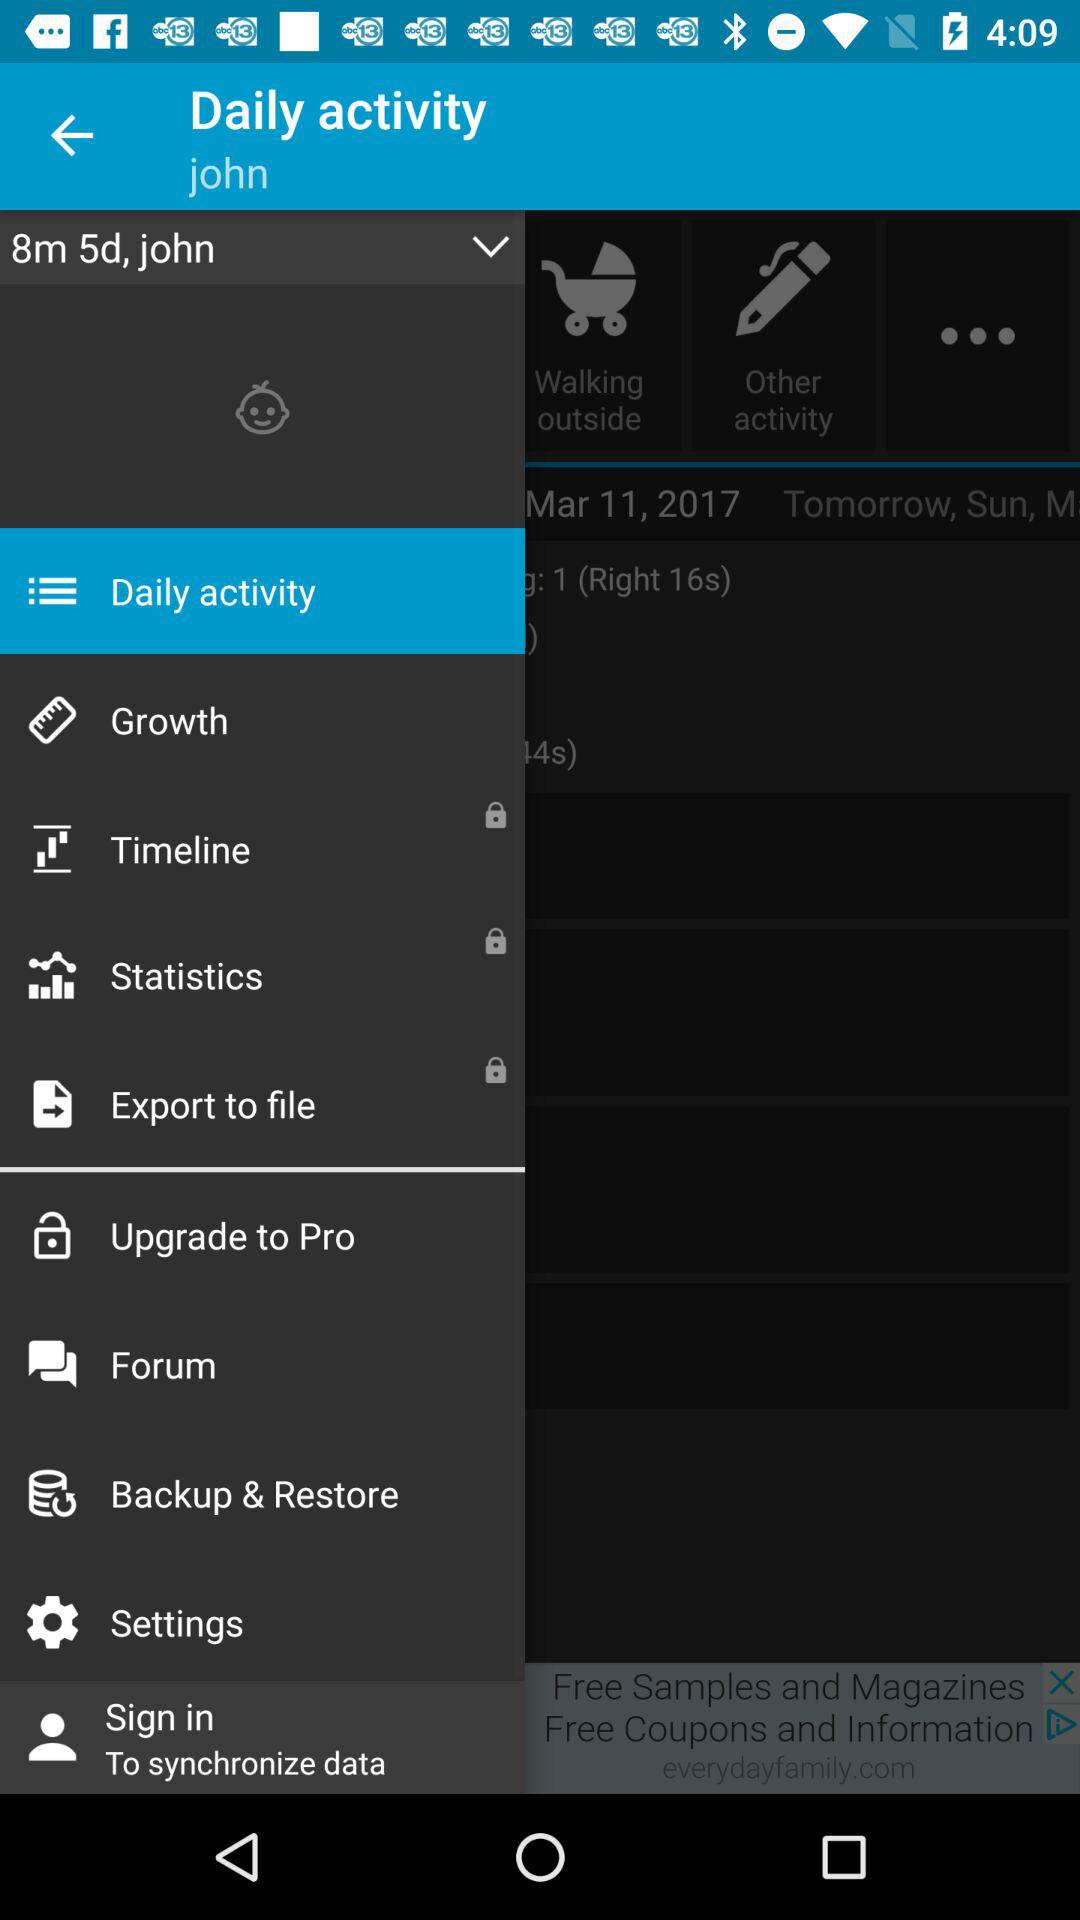How tall is the baby now?
When the provided information is insufficient, respond with <no answer>. <no answer> 